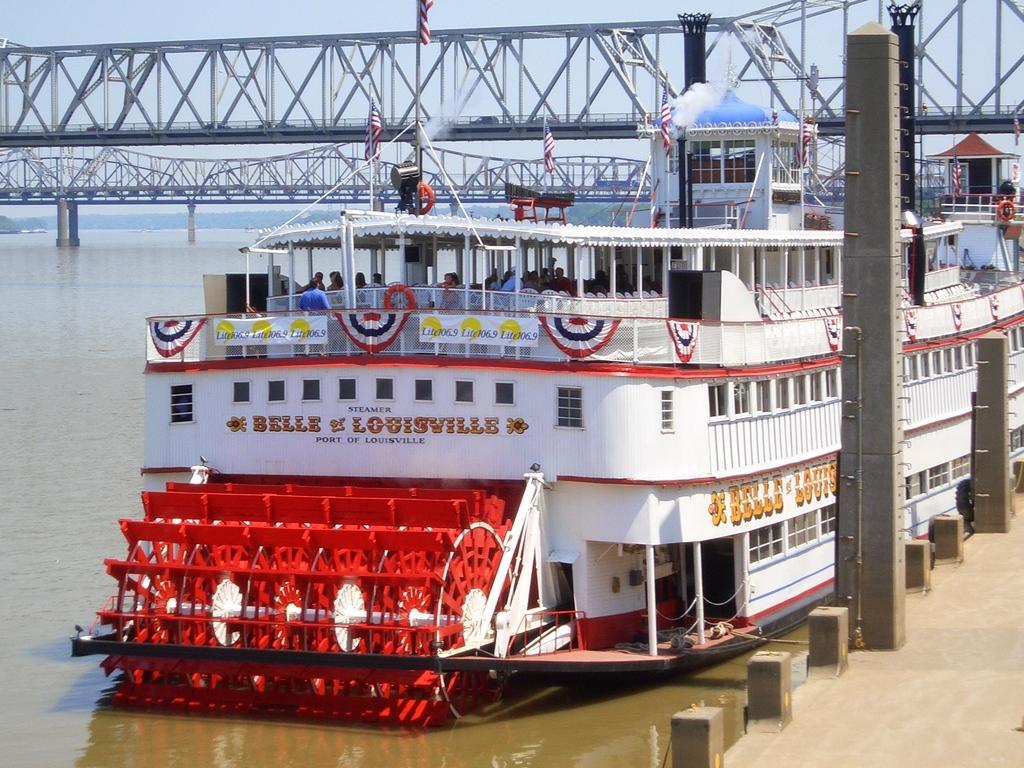Describe this image in one or two sentences. In the center of the image there is a ship with flags. In the background of the image there is a bridge. At the bottom of the image there is water. To the right side of the image there is a floor. There are poles. 